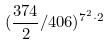Convert formula to latex. <formula><loc_0><loc_0><loc_500><loc_500>( \frac { 3 7 4 } { 2 } / 4 0 6 ) ^ { 7 ^ { 2 } \cdot 2 }</formula> 